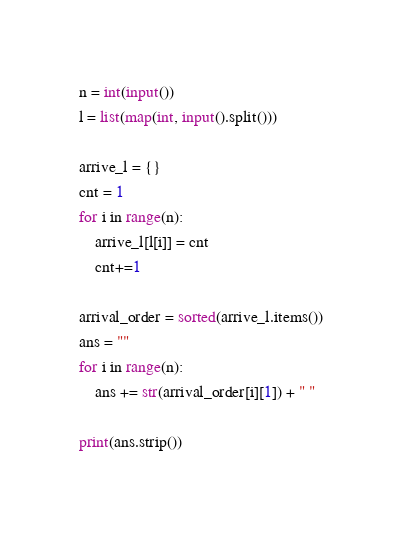<code> <loc_0><loc_0><loc_500><loc_500><_Python_>n = int(input())
l = list(map(int, input().split()))

arrive_l = {}
cnt = 1
for i in range(n):
    arrive_l[l[i]] = cnt
    cnt+=1

arrival_order = sorted(arrive_l.items())
ans = ""
for i in range(n):
    ans += str(arrival_order[i][1]) + " "
    
print(ans.strip())</code> 